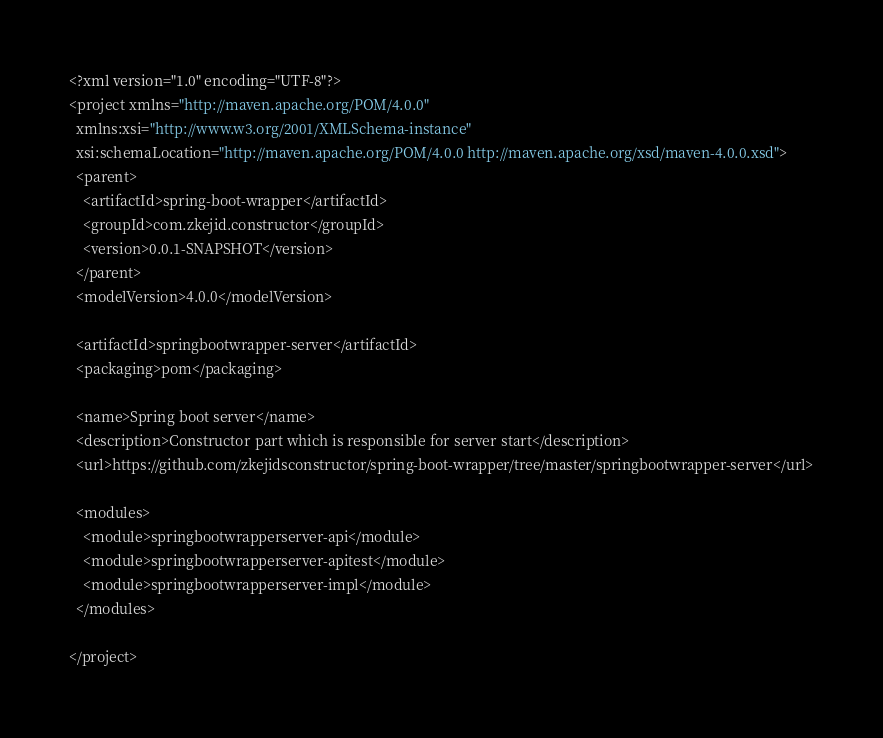Convert code to text. <code><loc_0><loc_0><loc_500><loc_500><_XML_><?xml version="1.0" encoding="UTF-8"?>
<project xmlns="http://maven.apache.org/POM/4.0.0"
  xmlns:xsi="http://www.w3.org/2001/XMLSchema-instance"
  xsi:schemaLocation="http://maven.apache.org/POM/4.0.0 http://maven.apache.org/xsd/maven-4.0.0.xsd">
  <parent>
    <artifactId>spring-boot-wrapper</artifactId>
    <groupId>com.zkejid.constructor</groupId>
    <version>0.0.1-SNAPSHOT</version>
  </parent>
  <modelVersion>4.0.0</modelVersion>

  <artifactId>springbootwrapper-server</artifactId>
  <packaging>pom</packaging>

  <name>Spring boot server</name>
  <description>Constructor part which is responsible for server start</description>
  <url>https://github.com/zkejidsconstructor/spring-boot-wrapper/tree/master/springbootwrapper-server</url>

  <modules>
    <module>springbootwrapperserver-api</module>
    <module>springbootwrapperserver-apitest</module>
    <module>springbootwrapperserver-impl</module>
  </modules>

</project></code> 